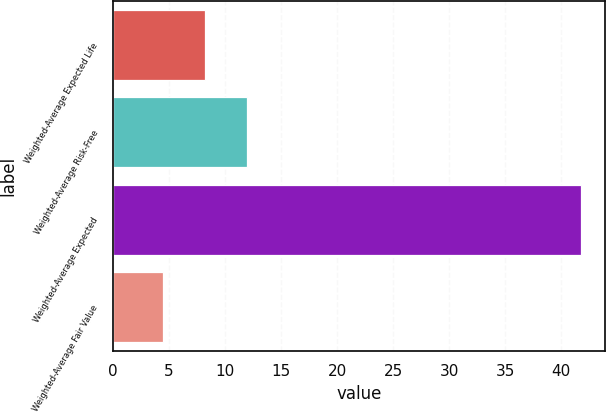Convert chart. <chart><loc_0><loc_0><loc_500><loc_500><bar_chart><fcel>Weighted-Average Expected Life<fcel>Weighted-Average Risk-Free<fcel>Weighted-Average Expected<fcel>Weighted-Average Fair Value<nl><fcel>8.18<fcel>11.91<fcel>41.8<fcel>4.45<nl></chart> 